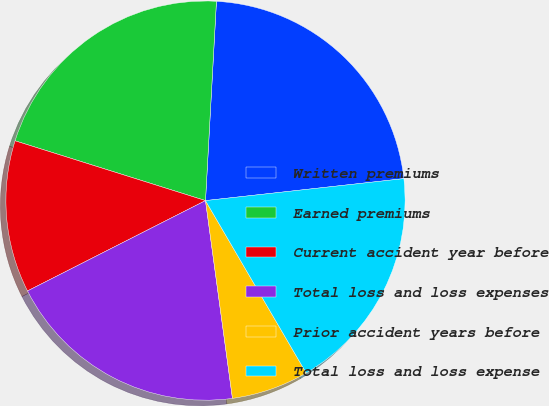Convert chart to OTSL. <chart><loc_0><loc_0><loc_500><loc_500><pie_chart><fcel>Written premiums<fcel>Earned premiums<fcel>Current accident year before<fcel>Total loss and loss expenses<fcel>Prior accident years before<fcel>Total loss and loss expense<nl><fcel>22.37%<fcel>21.03%<fcel>12.32%<fcel>19.68%<fcel>6.26%<fcel>18.34%<nl></chart> 